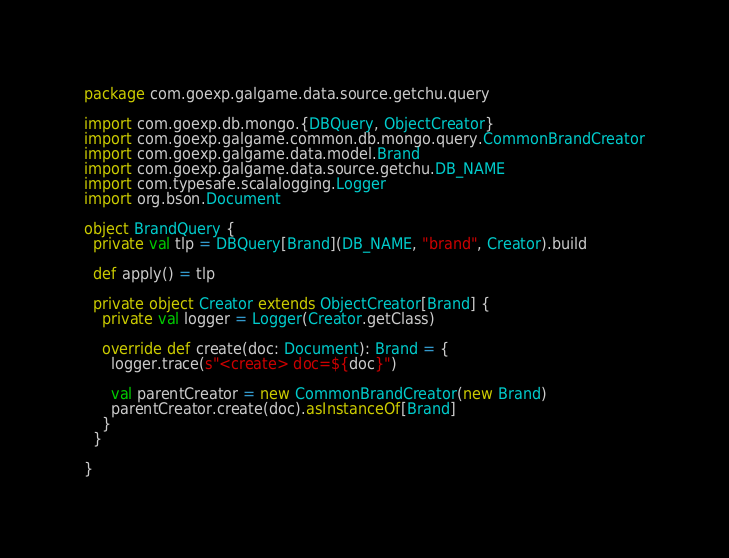Convert code to text. <code><loc_0><loc_0><loc_500><loc_500><_Scala_>package com.goexp.galgame.data.source.getchu.query

import com.goexp.db.mongo.{DBQuery, ObjectCreator}
import com.goexp.galgame.common.db.mongo.query.CommonBrandCreator
import com.goexp.galgame.data.model.Brand
import com.goexp.galgame.data.source.getchu.DB_NAME
import com.typesafe.scalalogging.Logger
import org.bson.Document

object BrandQuery {
  private val tlp = DBQuery[Brand](DB_NAME, "brand", Creator).build

  def apply() = tlp

  private object Creator extends ObjectCreator[Brand] {
    private val logger = Logger(Creator.getClass)

    override def create(doc: Document): Brand = {
      logger.trace(s"<create> doc=${doc}")

      val parentCreator = new CommonBrandCreator(new Brand)
      parentCreator.create(doc).asInstanceOf[Brand]
    }
  }

}</code> 